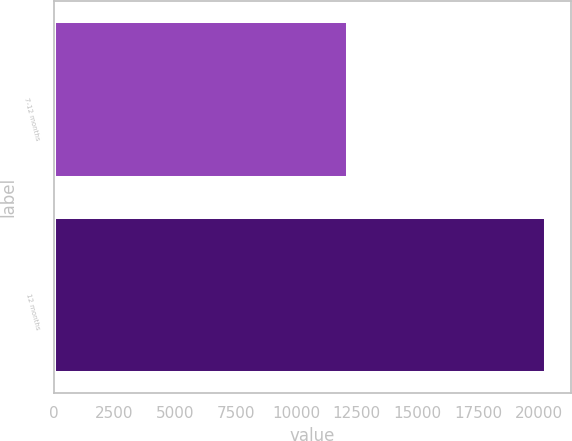<chart> <loc_0><loc_0><loc_500><loc_500><bar_chart><fcel>7-12 months<fcel>12 months<nl><fcel>12152<fcel>20330<nl></chart> 